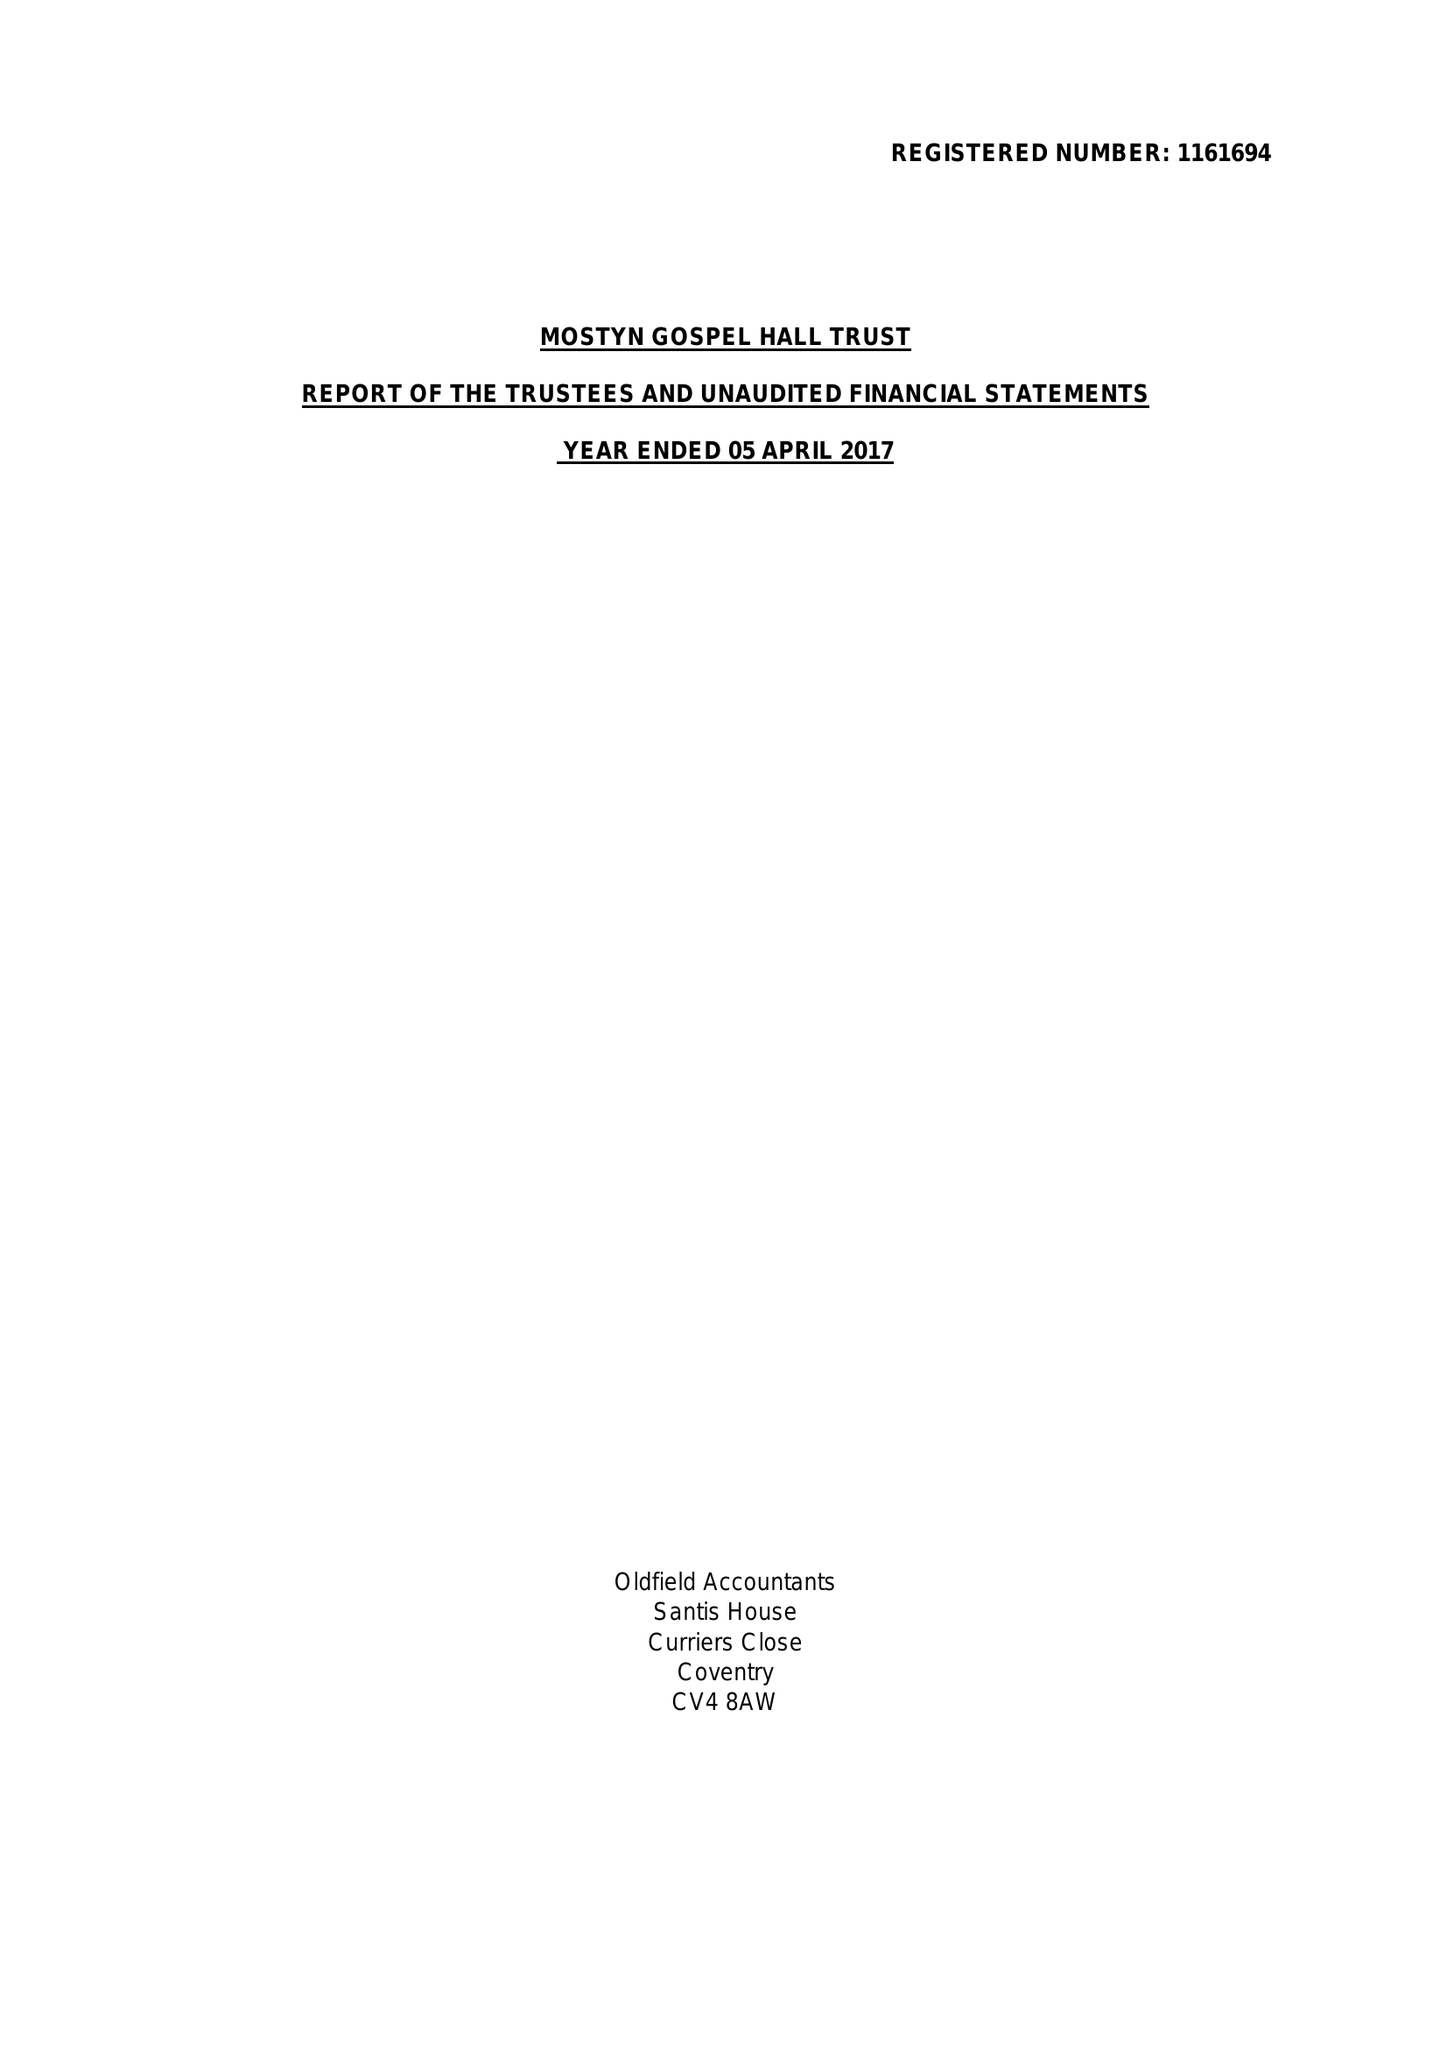What is the value for the address__post_town?
Answer the question using a single word or phrase. LEICESTER 